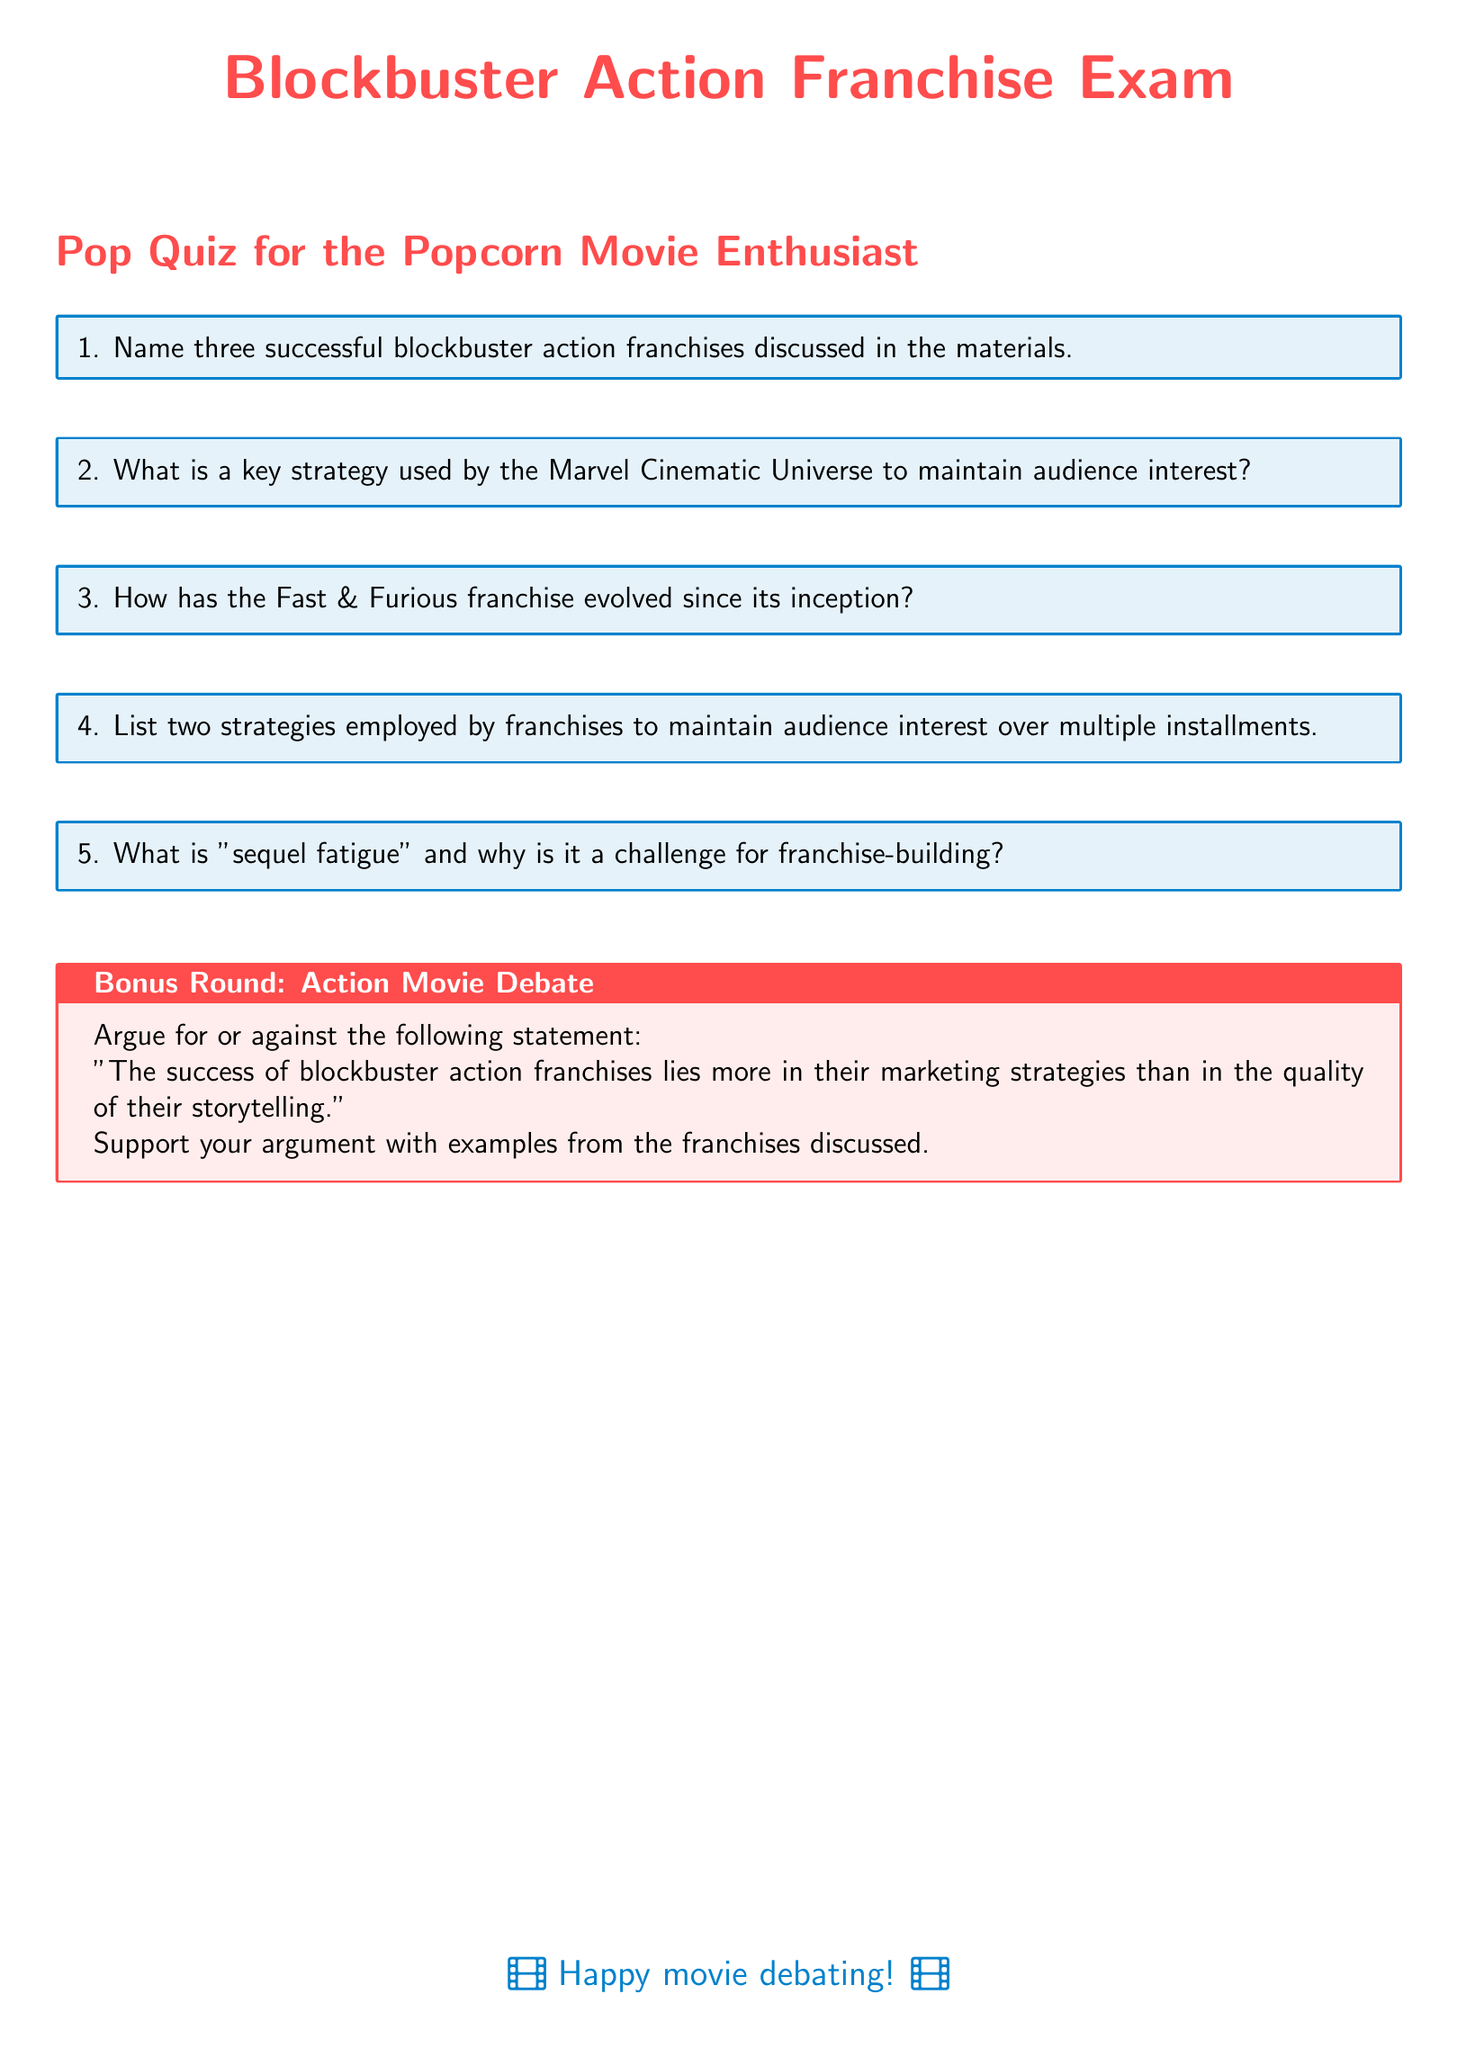What are the three successful blockbuster action franchises? The three franchises are discussed in the first question section of the document.
Answer: Name three successful blockbuster action franchises What is a key strategy used by the Marvel Cinematic Universe? A key strategy is mentioned in the second question section of the document.
Answer: What is a key strategy used by the Marvel Cinematic Universe to maintain audience interest? How has the Fast & Furious franchise evolved? The evolution of the franchise is covered in the third question section of the document.
Answer: How has the Fast & Furious franchise evolved since its inception? List two strategies employed by franchises. The strategies for maintaining audience interest are specified in the fourth question section of the document.
Answer: List two strategies employed by franchises to maintain audience interest over multiple installments What is "sequel fatigue"? "Sequel fatigue" is defined in the fifth question section of the document and its challenge for franchise-building is explained.
Answer: What is "sequel fatigue" and why is it a challenge for franchise-building? What does the bonus round argue? The bonus round presents a statement to argue for or against regarding marketing vs. storytelling.
Answer: Argue for or against the statement: "The success of blockbuster action franchises lies more in their marketing strategies than in the quality of their storytelling." 